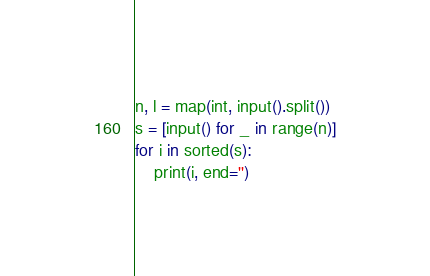Convert code to text. <code><loc_0><loc_0><loc_500><loc_500><_Python_>n, l = map(int, input().split())
s = [input() for _ in range(n)]
for i in sorted(s):
    print(i, end='')</code> 